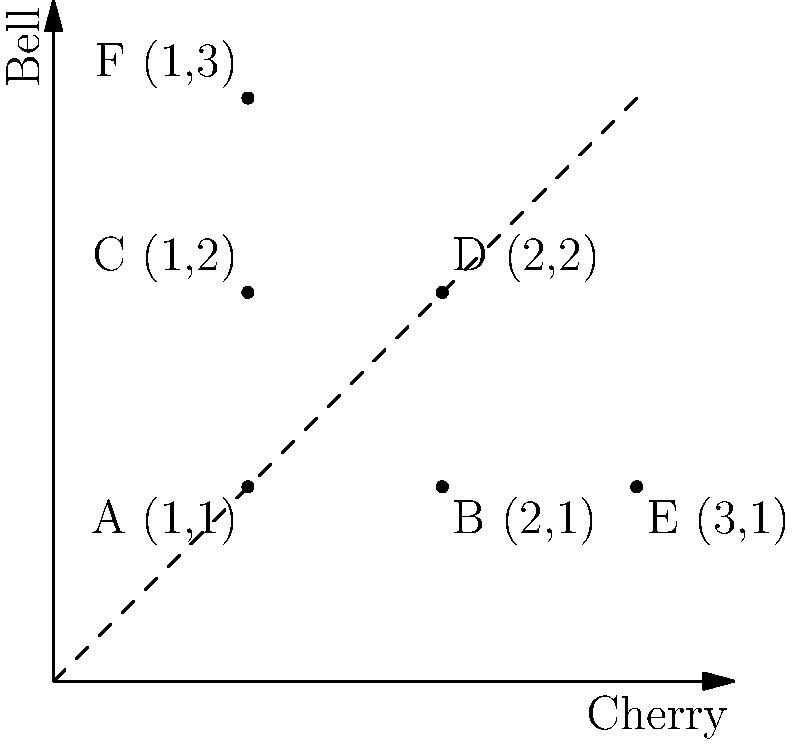A new slot machine uses a coordinate system to determine payouts. The x-axis represents the number of cherries, and the y-axis represents the number of bells. Each point on the plane corresponds to a specific payout:

A(1,1): $\$5$
B(2,1): $\$10$
C(1,2): $\$15$
D(2,2): $\$25$
E(3,1): $\$20$
F(1,3): $\$30$

If the probability of getting each combination is equally likely, what is the expected value of a single play on this slot machine? To calculate the expected value, we need to follow these steps:

1. Determine the total number of possible outcomes:
   There are 6 possible outcomes (A, B, C, D, E, F).

2. Calculate the probability of each outcome:
   Since all outcomes are equally likely, the probability of each is $\frac{1}{6}$.

3. Multiply each payout by its probability:
   A: $\$5 \times \frac{1}{6} = \frac{5}{6}$
   B: $\$10 \times \frac{1}{6} = \frac{10}{6}$
   C: $\$15 \times \frac{1}{6} = \frac{15}{6}$
   D: $\$25 \times \frac{1}{6} = \frac{25}{6}$
   E: $\$20 \times \frac{1}{6} = \frac{20}{6}$
   F: $\$30 \times \frac{1}{6} = \frac{30}{6}$

4. Sum up all the calculated values:
   $\frac{5}{6} + \frac{10}{6} + \frac{15}{6} + \frac{25}{6} + \frac{20}{6} + \frac{30}{6} = \frac{105}{6} = \$17.50$

Therefore, the expected value of a single play on this slot machine is $\$17.50$.
Answer: $\$17.50$ 